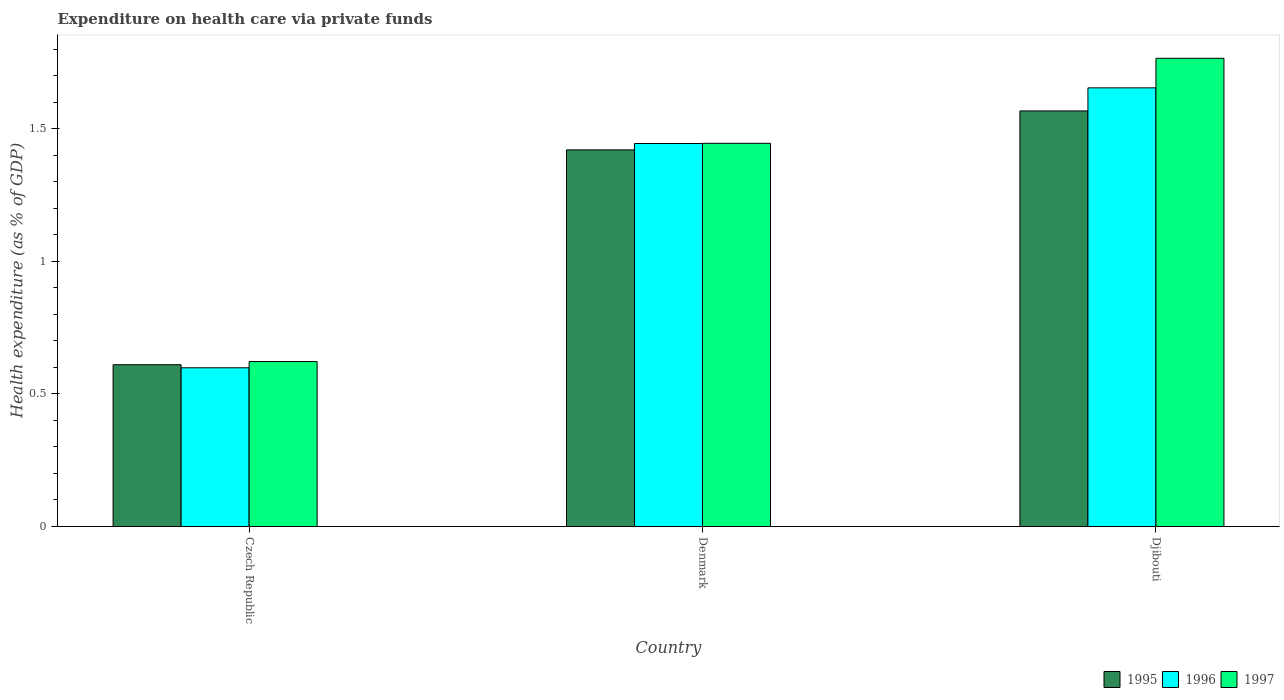How many groups of bars are there?
Give a very brief answer. 3. Are the number of bars on each tick of the X-axis equal?
Offer a terse response. Yes. How many bars are there on the 1st tick from the left?
Offer a terse response. 3. What is the label of the 1st group of bars from the left?
Your answer should be very brief. Czech Republic. What is the expenditure made on health care in 1995 in Djibouti?
Your answer should be very brief. 1.57. Across all countries, what is the maximum expenditure made on health care in 1997?
Offer a terse response. 1.77. Across all countries, what is the minimum expenditure made on health care in 1997?
Offer a terse response. 0.62. In which country was the expenditure made on health care in 1997 maximum?
Ensure brevity in your answer.  Djibouti. In which country was the expenditure made on health care in 1997 minimum?
Provide a succinct answer. Czech Republic. What is the total expenditure made on health care in 1996 in the graph?
Offer a very short reply. 3.7. What is the difference between the expenditure made on health care in 1996 in Czech Republic and that in Denmark?
Your answer should be very brief. -0.85. What is the difference between the expenditure made on health care in 1996 in Djibouti and the expenditure made on health care in 1995 in Czech Republic?
Offer a very short reply. 1.04. What is the average expenditure made on health care in 1996 per country?
Keep it short and to the point. 1.23. What is the difference between the expenditure made on health care of/in 1996 and expenditure made on health care of/in 1997 in Djibouti?
Make the answer very short. -0.11. In how many countries, is the expenditure made on health care in 1995 greater than 0.8 %?
Your answer should be very brief. 2. What is the ratio of the expenditure made on health care in 1995 in Denmark to that in Djibouti?
Provide a short and direct response. 0.91. Is the expenditure made on health care in 1995 in Czech Republic less than that in Djibouti?
Give a very brief answer. Yes. Is the difference between the expenditure made on health care in 1996 in Czech Republic and Denmark greater than the difference between the expenditure made on health care in 1997 in Czech Republic and Denmark?
Provide a succinct answer. No. What is the difference between the highest and the second highest expenditure made on health care in 1996?
Provide a succinct answer. -1.06. What is the difference between the highest and the lowest expenditure made on health care in 1995?
Your answer should be very brief. 0.96. In how many countries, is the expenditure made on health care in 1996 greater than the average expenditure made on health care in 1996 taken over all countries?
Provide a succinct answer. 2. How many bars are there?
Your answer should be very brief. 9. Are all the bars in the graph horizontal?
Keep it short and to the point. No. What is the difference between two consecutive major ticks on the Y-axis?
Your answer should be very brief. 0.5. Does the graph contain any zero values?
Your answer should be compact. No. Does the graph contain grids?
Your answer should be compact. No. How are the legend labels stacked?
Keep it short and to the point. Horizontal. What is the title of the graph?
Provide a short and direct response. Expenditure on health care via private funds. Does "1982" appear as one of the legend labels in the graph?
Offer a very short reply. No. What is the label or title of the Y-axis?
Your answer should be compact. Health expenditure (as % of GDP). What is the Health expenditure (as % of GDP) of 1995 in Czech Republic?
Your answer should be compact. 0.61. What is the Health expenditure (as % of GDP) in 1996 in Czech Republic?
Provide a succinct answer. 0.6. What is the Health expenditure (as % of GDP) in 1997 in Czech Republic?
Provide a succinct answer. 0.62. What is the Health expenditure (as % of GDP) in 1995 in Denmark?
Provide a short and direct response. 1.42. What is the Health expenditure (as % of GDP) of 1996 in Denmark?
Ensure brevity in your answer.  1.44. What is the Health expenditure (as % of GDP) of 1997 in Denmark?
Keep it short and to the point. 1.44. What is the Health expenditure (as % of GDP) of 1995 in Djibouti?
Provide a short and direct response. 1.57. What is the Health expenditure (as % of GDP) in 1996 in Djibouti?
Ensure brevity in your answer.  1.65. What is the Health expenditure (as % of GDP) of 1997 in Djibouti?
Your response must be concise. 1.77. Across all countries, what is the maximum Health expenditure (as % of GDP) in 1995?
Provide a succinct answer. 1.57. Across all countries, what is the maximum Health expenditure (as % of GDP) of 1996?
Your answer should be very brief. 1.65. Across all countries, what is the maximum Health expenditure (as % of GDP) of 1997?
Ensure brevity in your answer.  1.77. Across all countries, what is the minimum Health expenditure (as % of GDP) of 1995?
Offer a terse response. 0.61. Across all countries, what is the minimum Health expenditure (as % of GDP) of 1996?
Ensure brevity in your answer.  0.6. Across all countries, what is the minimum Health expenditure (as % of GDP) in 1997?
Your response must be concise. 0.62. What is the total Health expenditure (as % of GDP) of 1995 in the graph?
Give a very brief answer. 3.6. What is the total Health expenditure (as % of GDP) of 1996 in the graph?
Make the answer very short. 3.7. What is the total Health expenditure (as % of GDP) of 1997 in the graph?
Make the answer very short. 3.83. What is the difference between the Health expenditure (as % of GDP) in 1995 in Czech Republic and that in Denmark?
Your answer should be very brief. -0.81. What is the difference between the Health expenditure (as % of GDP) of 1996 in Czech Republic and that in Denmark?
Offer a terse response. -0.85. What is the difference between the Health expenditure (as % of GDP) of 1997 in Czech Republic and that in Denmark?
Offer a very short reply. -0.82. What is the difference between the Health expenditure (as % of GDP) of 1995 in Czech Republic and that in Djibouti?
Ensure brevity in your answer.  -0.96. What is the difference between the Health expenditure (as % of GDP) of 1996 in Czech Republic and that in Djibouti?
Offer a very short reply. -1.06. What is the difference between the Health expenditure (as % of GDP) of 1997 in Czech Republic and that in Djibouti?
Offer a very short reply. -1.14. What is the difference between the Health expenditure (as % of GDP) of 1995 in Denmark and that in Djibouti?
Your response must be concise. -0.15. What is the difference between the Health expenditure (as % of GDP) of 1996 in Denmark and that in Djibouti?
Give a very brief answer. -0.21. What is the difference between the Health expenditure (as % of GDP) in 1997 in Denmark and that in Djibouti?
Provide a succinct answer. -0.32. What is the difference between the Health expenditure (as % of GDP) in 1995 in Czech Republic and the Health expenditure (as % of GDP) in 1996 in Denmark?
Provide a succinct answer. -0.83. What is the difference between the Health expenditure (as % of GDP) in 1995 in Czech Republic and the Health expenditure (as % of GDP) in 1997 in Denmark?
Make the answer very short. -0.83. What is the difference between the Health expenditure (as % of GDP) in 1996 in Czech Republic and the Health expenditure (as % of GDP) in 1997 in Denmark?
Offer a terse response. -0.85. What is the difference between the Health expenditure (as % of GDP) of 1995 in Czech Republic and the Health expenditure (as % of GDP) of 1996 in Djibouti?
Keep it short and to the point. -1.04. What is the difference between the Health expenditure (as % of GDP) in 1995 in Czech Republic and the Health expenditure (as % of GDP) in 1997 in Djibouti?
Your response must be concise. -1.16. What is the difference between the Health expenditure (as % of GDP) of 1996 in Czech Republic and the Health expenditure (as % of GDP) of 1997 in Djibouti?
Make the answer very short. -1.17. What is the difference between the Health expenditure (as % of GDP) of 1995 in Denmark and the Health expenditure (as % of GDP) of 1996 in Djibouti?
Keep it short and to the point. -0.23. What is the difference between the Health expenditure (as % of GDP) in 1995 in Denmark and the Health expenditure (as % of GDP) in 1997 in Djibouti?
Make the answer very short. -0.35. What is the difference between the Health expenditure (as % of GDP) in 1996 in Denmark and the Health expenditure (as % of GDP) in 1997 in Djibouti?
Ensure brevity in your answer.  -0.32. What is the average Health expenditure (as % of GDP) of 1995 per country?
Offer a terse response. 1.2. What is the average Health expenditure (as % of GDP) in 1996 per country?
Provide a succinct answer. 1.23. What is the average Health expenditure (as % of GDP) of 1997 per country?
Provide a succinct answer. 1.28. What is the difference between the Health expenditure (as % of GDP) of 1995 and Health expenditure (as % of GDP) of 1996 in Czech Republic?
Offer a terse response. 0.01. What is the difference between the Health expenditure (as % of GDP) in 1995 and Health expenditure (as % of GDP) in 1997 in Czech Republic?
Your answer should be compact. -0.01. What is the difference between the Health expenditure (as % of GDP) in 1996 and Health expenditure (as % of GDP) in 1997 in Czech Republic?
Keep it short and to the point. -0.02. What is the difference between the Health expenditure (as % of GDP) in 1995 and Health expenditure (as % of GDP) in 1996 in Denmark?
Offer a very short reply. -0.02. What is the difference between the Health expenditure (as % of GDP) of 1995 and Health expenditure (as % of GDP) of 1997 in Denmark?
Give a very brief answer. -0.02. What is the difference between the Health expenditure (as % of GDP) in 1996 and Health expenditure (as % of GDP) in 1997 in Denmark?
Your response must be concise. -0. What is the difference between the Health expenditure (as % of GDP) of 1995 and Health expenditure (as % of GDP) of 1996 in Djibouti?
Offer a very short reply. -0.09. What is the difference between the Health expenditure (as % of GDP) of 1995 and Health expenditure (as % of GDP) of 1997 in Djibouti?
Your response must be concise. -0.2. What is the difference between the Health expenditure (as % of GDP) of 1996 and Health expenditure (as % of GDP) of 1997 in Djibouti?
Give a very brief answer. -0.11. What is the ratio of the Health expenditure (as % of GDP) in 1995 in Czech Republic to that in Denmark?
Ensure brevity in your answer.  0.43. What is the ratio of the Health expenditure (as % of GDP) of 1996 in Czech Republic to that in Denmark?
Keep it short and to the point. 0.41. What is the ratio of the Health expenditure (as % of GDP) of 1997 in Czech Republic to that in Denmark?
Provide a short and direct response. 0.43. What is the ratio of the Health expenditure (as % of GDP) of 1995 in Czech Republic to that in Djibouti?
Your response must be concise. 0.39. What is the ratio of the Health expenditure (as % of GDP) in 1996 in Czech Republic to that in Djibouti?
Offer a terse response. 0.36. What is the ratio of the Health expenditure (as % of GDP) of 1997 in Czech Republic to that in Djibouti?
Offer a terse response. 0.35. What is the ratio of the Health expenditure (as % of GDP) of 1995 in Denmark to that in Djibouti?
Offer a very short reply. 0.91. What is the ratio of the Health expenditure (as % of GDP) in 1996 in Denmark to that in Djibouti?
Provide a succinct answer. 0.87. What is the ratio of the Health expenditure (as % of GDP) of 1997 in Denmark to that in Djibouti?
Offer a terse response. 0.82. What is the difference between the highest and the second highest Health expenditure (as % of GDP) in 1995?
Provide a short and direct response. 0.15. What is the difference between the highest and the second highest Health expenditure (as % of GDP) in 1996?
Ensure brevity in your answer.  0.21. What is the difference between the highest and the second highest Health expenditure (as % of GDP) of 1997?
Make the answer very short. 0.32. What is the difference between the highest and the lowest Health expenditure (as % of GDP) in 1995?
Provide a succinct answer. 0.96. What is the difference between the highest and the lowest Health expenditure (as % of GDP) of 1996?
Give a very brief answer. 1.06. What is the difference between the highest and the lowest Health expenditure (as % of GDP) in 1997?
Provide a succinct answer. 1.14. 